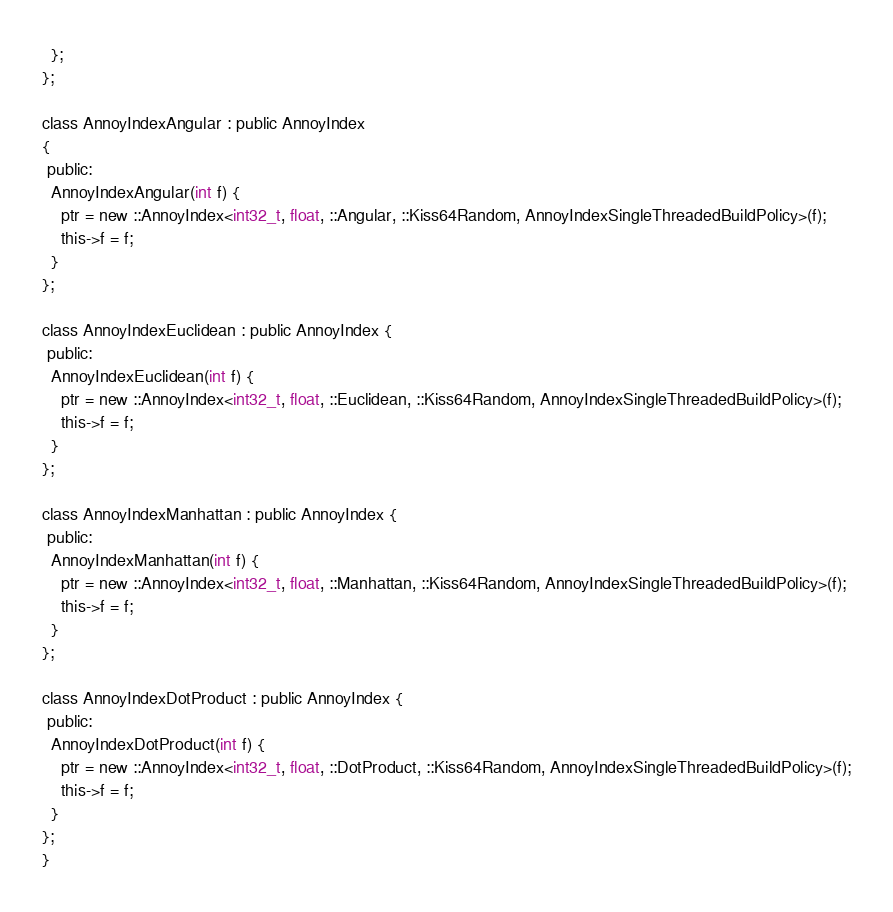Convert code to text. <code><loc_0><loc_0><loc_500><loc_500><_C_>  };
};

class AnnoyIndexAngular : public AnnoyIndex 
{
 public:
  AnnoyIndexAngular(int f) {
    ptr = new ::AnnoyIndex<int32_t, float, ::Angular, ::Kiss64Random, AnnoyIndexSingleThreadedBuildPolicy>(f);
    this->f = f;
  }
};

class AnnoyIndexEuclidean : public AnnoyIndex {
 public:
  AnnoyIndexEuclidean(int f) {
    ptr = new ::AnnoyIndex<int32_t, float, ::Euclidean, ::Kiss64Random, AnnoyIndexSingleThreadedBuildPolicy>(f);
    this->f = f;
  }
};

class AnnoyIndexManhattan : public AnnoyIndex {
 public:
  AnnoyIndexManhattan(int f) {
    ptr = new ::AnnoyIndex<int32_t, float, ::Manhattan, ::Kiss64Random, AnnoyIndexSingleThreadedBuildPolicy>(f);
    this->f = f;
  }
};

class AnnoyIndexDotProduct : public AnnoyIndex {
 public:
  AnnoyIndexDotProduct(int f) {
    ptr = new ::AnnoyIndex<int32_t, float, ::DotProduct, ::Kiss64Random, AnnoyIndexSingleThreadedBuildPolicy>(f);
    this->f = f;
  }
};
}
</code> 